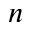Convert formula to latex. <formula><loc_0><loc_0><loc_500><loc_500>n</formula> 